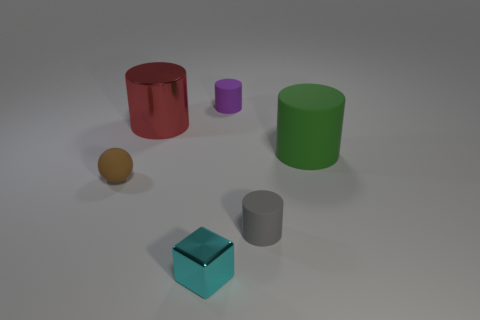Subtract 1 cylinders. How many cylinders are left? 3 Add 4 big gray cylinders. How many objects exist? 10 Subtract all spheres. How many objects are left? 5 Add 1 green rubber cylinders. How many green rubber cylinders are left? 2 Add 6 red cylinders. How many red cylinders exist? 7 Subtract 0 yellow spheres. How many objects are left? 6 Subtract all blocks. Subtract all red metallic spheres. How many objects are left? 5 